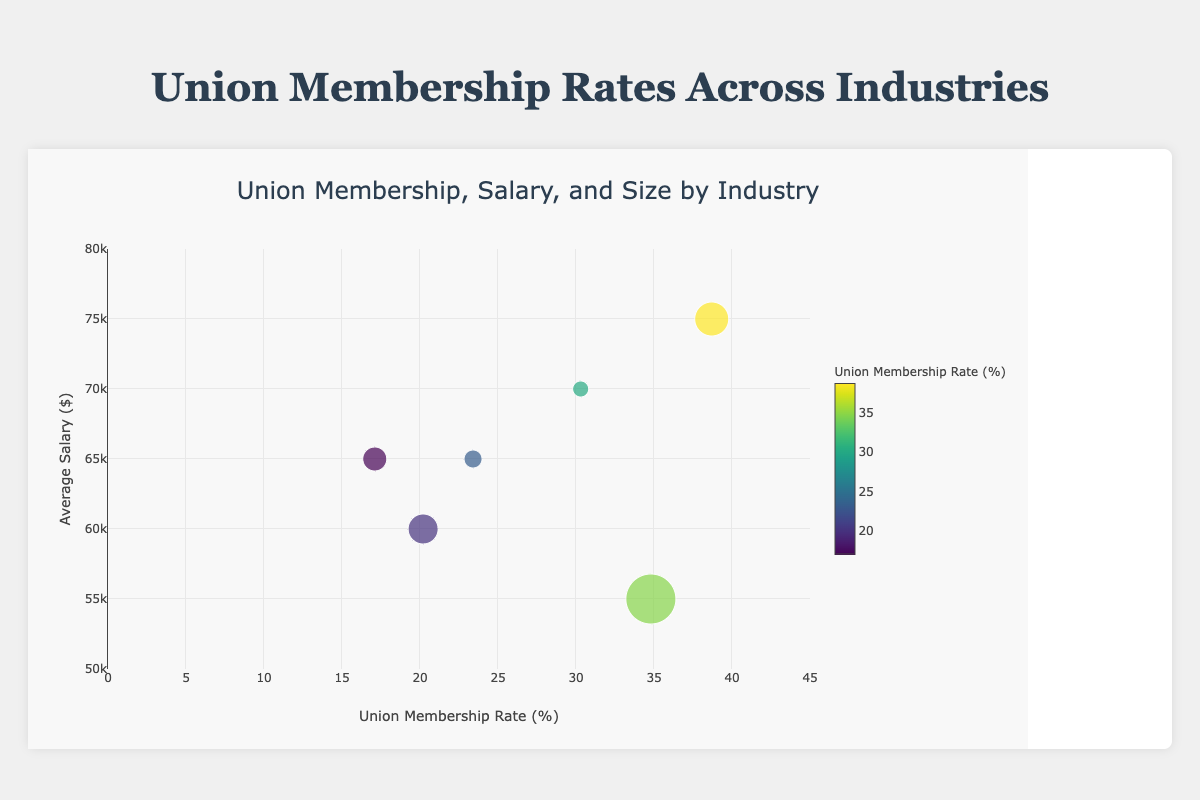What industry has the highest union membership rate? By inspecting the x-axis of the Bubble Chart, we can see that "Public Administration" has the highest union membership rate as it is farthest to the right on the chart.
Answer: Public Administration How many industries have an average salary of $65000? By looking at the y-axis, we can see that both "Healthcare" and "Transportation" are plotted at $65000 average salary. There are two industries.
Answer: Two industries Which industry has the largest number of union members? The size of the bubbles indicates the number of union members. "Education" has the largest bubble, indicating it has the largest number of union members.
Answer: Education Which industry has the smallest union membership rate? By looking at the x-axis, "Healthcare" is the furthest left, indicating it has the smallest union membership rate.
Answer: Healthcare Compare the average salaries between the Education and Construction industries. Which is higher and by how much? "Construction" has an average salary of $70000, while "Education" has an average salary of $55000. The difference is $70000 - $55000 = $15000.
Answer: Construction by $15000 What is the median union membership rate among the industries represented? The union membership rates are 34.8, 17.1, 30.3, 20.2, 38.7, and 23.4. Sorted, they are 17.1, 20.2, 23.4, 30.3, 34.8, and 38.7. The median of these six numbers is (23.4 + 30.3)/2 = 26.85.
Answer: 26.85% Where does Transportation fall in terms of union membership rate relative to other industries? Transportation has a union membership rate of 23.4%, placing it higher than Healthcare (17.1%), Manufacturing (20.2%), but lower than Education (34.8%), Construction (30.3%), and Public Administration (38.7%).
Answer: Middle Does a higher average salary correlate with a higher union membership rate in this data? Observing the chart, there doesn't appear to be a strong correlation. For example, Public Administration has the highest membership rate but is not the highest salary. Construction has a high average salary but not the highest membership rate.
Answer: No How does the union membership rate in Manufacturing compare to Transportation? Manufacturing has a union membership rate of 20.2%, while Transportation has a rate of 23.4%. Therefore, Transportation has a higher union membership rate by 3.2%.
Answer: Transportation by 3.2% 